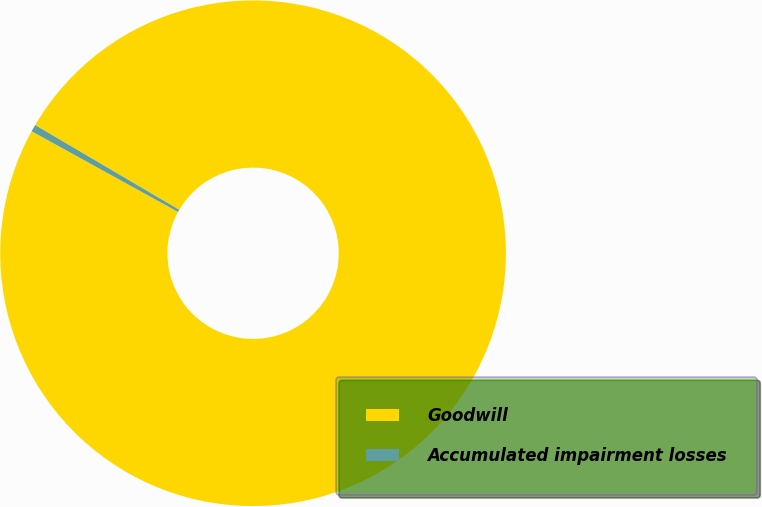Convert chart to OTSL. <chart><loc_0><loc_0><loc_500><loc_500><pie_chart><fcel>Goodwill<fcel>Accumulated impairment losses<nl><fcel>99.55%<fcel>0.45%<nl></chart> 